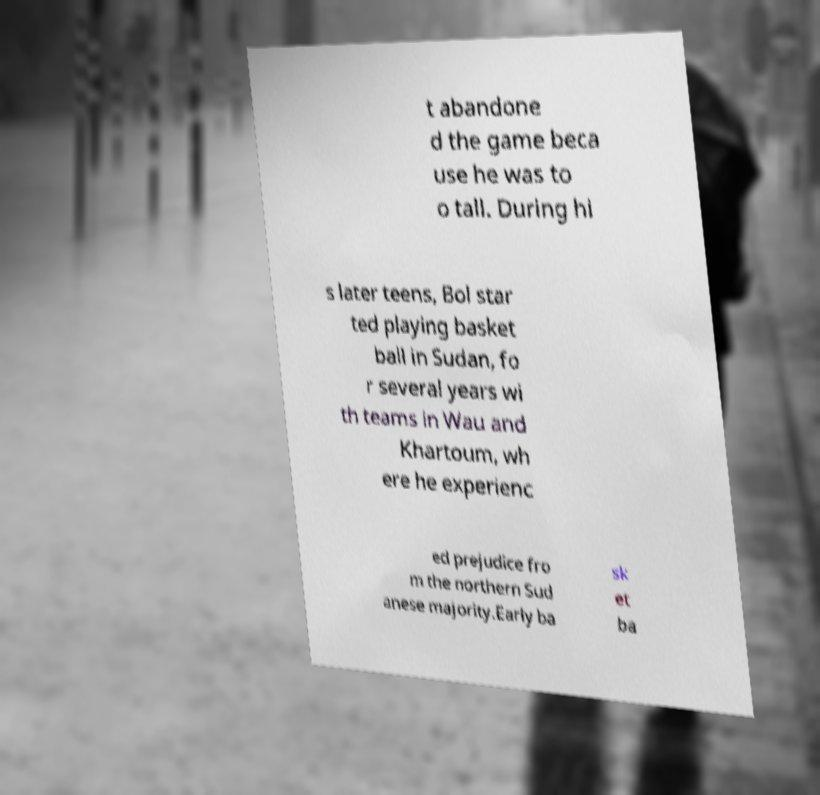Could you extract and type out the text from this image? t abandone d the game beca use he was to o tall. During hi s later teens, Bol star ted playing basket ball in Sudan, fo r several years wi th teams in Wau and Khartoum, wh ere he experienc ed prejudice fro m the northern Sud anese majority.Early ba sk et ba 